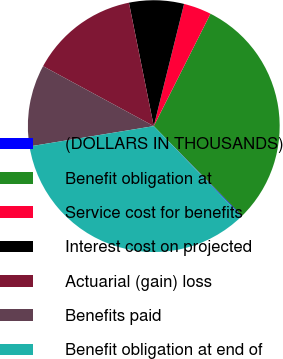Convert chart to OTSL. <chart><loc_0><loc_0><loc_500><loc_500><pie_chart><fcel>(DOLLARS IN THOUSANDS)<fcel>Benefit obligation at<fcel>Service cost for benefits<fcel>Interest cost on projected<fcel>Actuarial (gain) loss<fcel>Benefits paid<fcel>Benefit obligation at end of<nl><fcel>0.11%<fcel>30.2%<fcel>3.57%<fcel>7.03%<fcel>13.94%<fcel>10.48%<fcel>34.68%<nl></chart> 